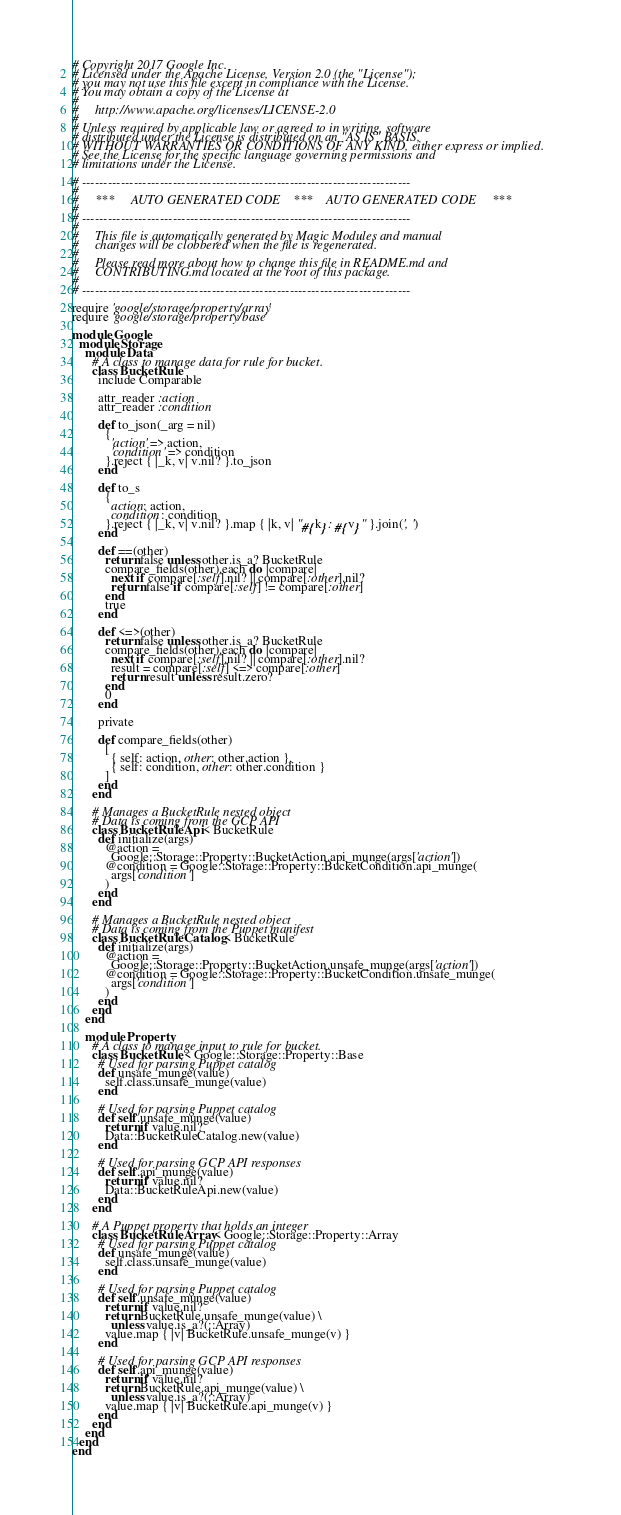<code> <loc_0><loc_0><loc_500><loc_500><_Ruby_># Copyright 2017 Google Inc.
# Licensed under the Apache License, Version 2.0 (the "License");
# you may not use this file except in compliance with the License.
# You may obtain a copy of the License at
#
#     http://www.apache.org/licenses/LICENSE-2.0
#
# Unless required by applicable law or agreed to in writing, software
# distributed under the License is distributed on an "AS IS" BASIS,
# WITHOUT WARRANTIES OR CONDITIONS OF ANY KIND, either express or implied.
# See the License for the specific language governing permissions and
# limitations under the License.

# ----------------------------------------------------------------------------
#
#     ***     AUTO GENERATED CODE    ***    AUTO GENERATED CODE     ***
#
# ----------------------------------------------------------------------------
#
#     This file is automatically generated by Magic Modules and manual
#     changes will be clobbered when the file is regenerated.
#
#     Please read more about how to change this file in README.md and
#     CONTRIBUTING.md located at the root of this package.
#
# ----------------------------------------------------------------------------

require 'google/storage/property/array'
require 'google/storage/property/base'

module Google
  module Storage
    module Data
      # A class to manage data for rule for bucket.
      class BucketRule
        include Comparable

        attr_reader :action
        attr_reader :condition

        def to_json(_arg = nil)
          {
            'action' => action,
            'condition' => condition
          }.reject { |_k, v| v.nil? }.to_json
        end

        def to_s
          {
            action: action,
            condition: condition
          }.reject { |_k, v| v.nil? }.map { |k, v| "#{k}: #{v}" }.join(', ')
        end

        def ==(other)
          return false unless other.is_a? BucketRule
          compare_fields(other).each do |compare|
            next if compare[:self].nil? || compare[:other].nil?
            return false if compare[:self] != compare[:other]
          end
          true
        end

        def <=>(other)
          return false unless other.is_a? BucketRule
          compare_fields(other).each do |compare|
            next if compare[:self].nil? || compare[:other].nil?
            result = compare[:self] <=> compare[:other]
            return result unless result.zero?
          end
          0
        end

        private

        def compare_fields(other)
          [
            { self: action, other: other.action },
            { self: condition, other: other.condition }
          ]
        end
      end

      # Manages a BucketRule nested object
      # Data is coming from the GCP API
      class BucketRuleApi < BucketRule
        def initialize(args)
          @action =
            Google::Storage::Property::BucketAction.api_munge(args['action'])
          @condition = Google::Storage::Property::BucketCondition.api_munge(
            args['condition']
          )
        end
      end

      # Manages a BucketRule nested object
      # Data is coming from the Puppet manifest
      class BucketRuleCatalog < BucketRule
        def initialize(args)
          @action =
            Google::Storage::Property::BucketAction.unsafe_munge(args['action'])
          @condition = Google::Storage::Property::BucketCondition.unsafe_munge(
            args['condition']
          )
        end
      end
    end

    module Property
      # A class to manage input to rule for bucket.
      class BucketRule < Google::Storage::Property::Base
        # Used for parsing Puppet catalog
        def unsafe_munge(value)
          self.class.unsafe_munge(value)
        end

        # Used for parsing Puppet catalog
        def self.unsafe_munge(value)
          return if value.nil?
          Data::BucketRuleCatalog.new(value)
        end

        # Used for parsing GCP API responses
        def self.api_munge(value)
          return if value.nil?
          Data::BucketRuleApi.new(value)
        end
      end

      # A Puppet property that holds an integer
      class BucketRuleArray < Google::Storage::Property::Array
        # Used for parsing Puppet catalog
        def unsafe_munge(value)
          self.class.unsafe_munge(value)
        end

        # Used for parsing Puppet catalog
        def self.unsafe_munge(value)
          return if value.nil?
          return BucketRule.unsafe_munge(value) \
            unless value.is_a?(::Array)
          value.map { |v| BucketRule.unsafe_munge(v) }
        end

        # Used for parsing GCP API responses
        def self.api_munge(value)
          return if value.nil?
          return BucketRule.api_munge(value) \
            unless value.is_a?(::Array)
          value.map { |v| BucketRule.api_munge(v) }
        end
      end
    end
  end
end
</code> 